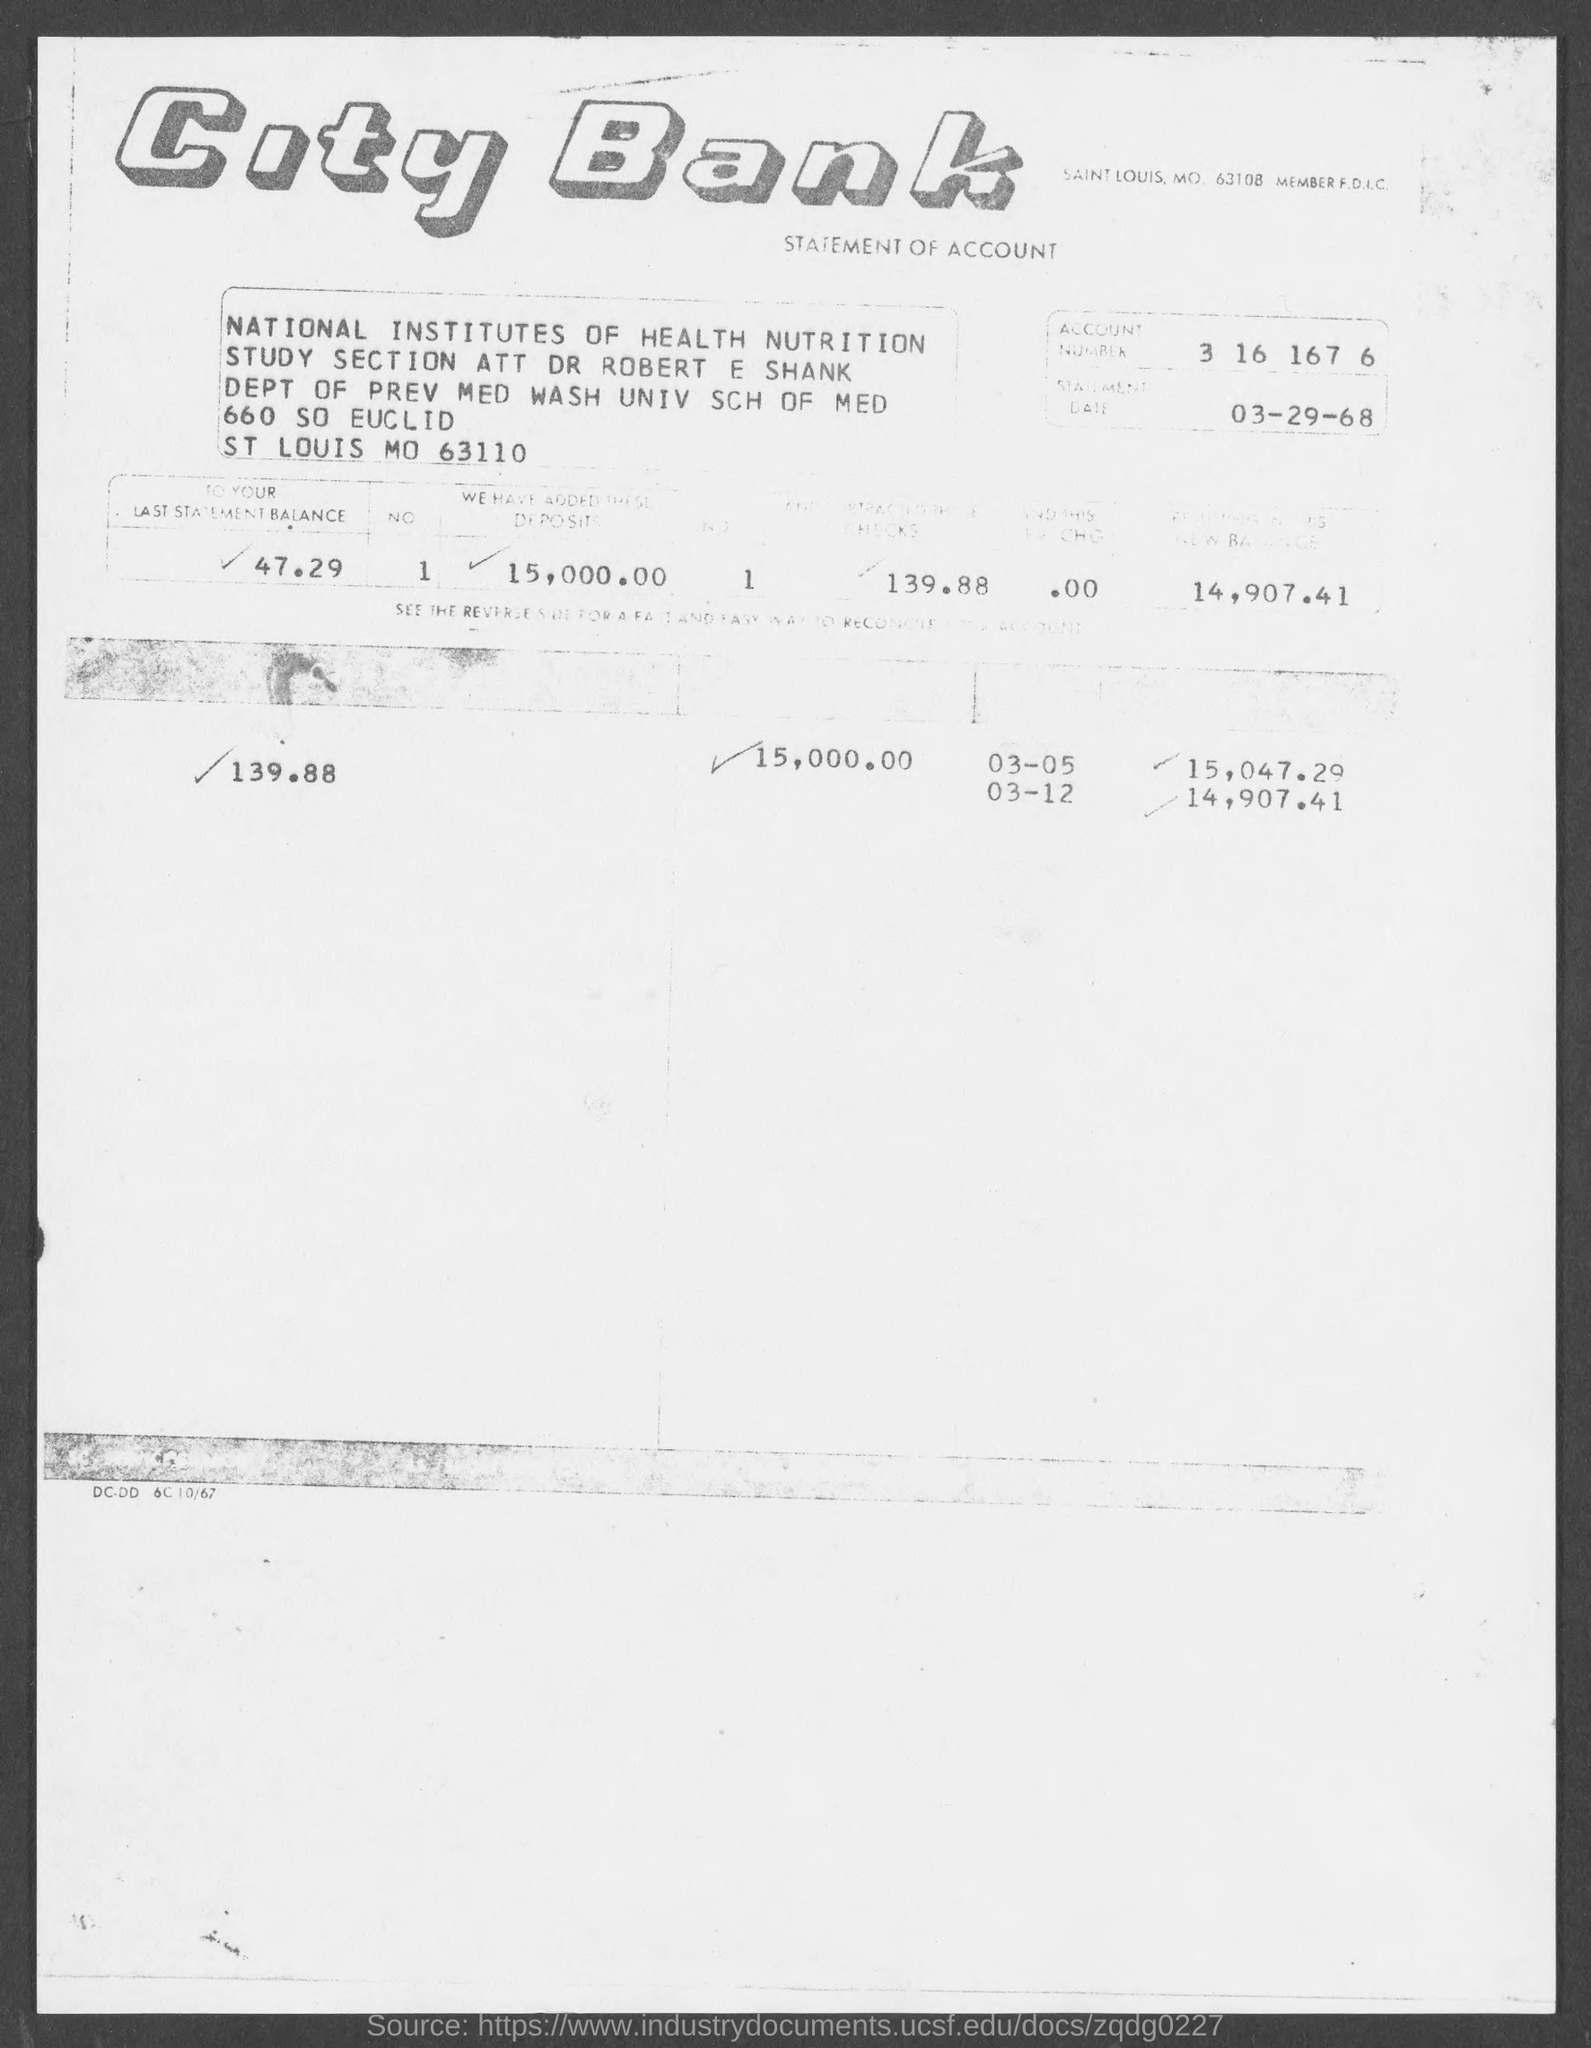Which bank's Statement of Account is this?
Offer a terse response. City Bank. What is the Account Number given in the statement?
Your response must be concise. 3 16 167 6. What is the statement date given?
Provide a short and direct response. 03-29-68. 